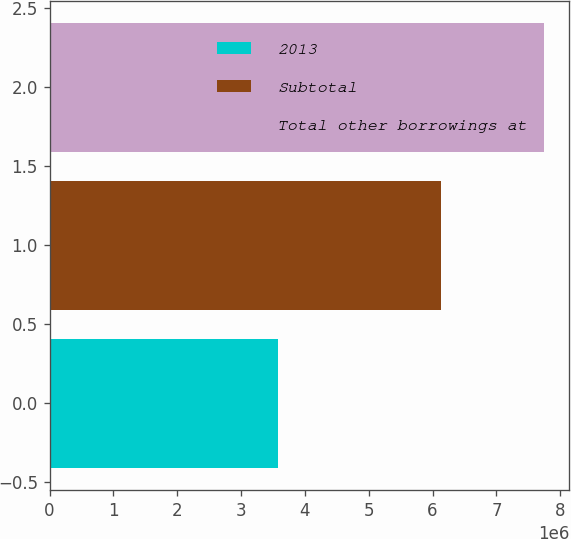Convert chart. <chart><loc_0><loc_0><loc_500><loc_500><bar_chart><fcel>2013<fcel>Subtotal<fcel>Total other borrowings at<nl><fcel>3.57367e+06<fcel>6.13345e+06<fcel>7.75243e+06<nl></chart> 